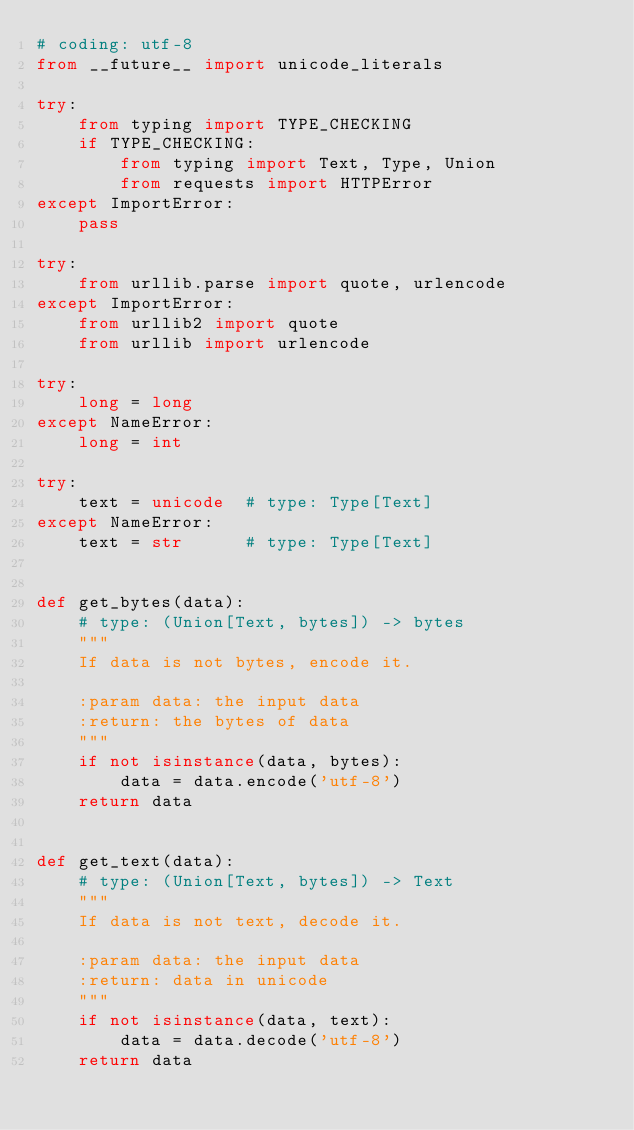<code> <loc_0><loc_0><loc_500><loc_500><_Python_># coding: utf-8
from __future__ import unicode_literals

try:
    from typing import TYPE_CHECKING
    if TYPE_CHECKING:
        from typing import Text, Type, Union
        from requests import HTTPError
except ImportError:
    pass

try:
    from urllib.parse import quote, urlencode
except ImportError:
    from urllib2 import quote
    from urllib import urlencode

try:
    long = long
except NameError:
    long = int

try:
    text = unicode  # type: Type[Text]
except NameError:
    text = str      # type: Type[Text]


def get_bytes(data):
    # type: (Union[Text, bytes]) -> bytes
    """
    If data is not bytes, encode it.

    :param data: the input data
    :return: the bytes of data
    """
    if not isinstance(data, bytes):
        data = data.encode('utf-8')
    return data


def get_text(data):
    # type: (Union[Text, bytes]) -> Text
    """
    If data is not text, decode it.

    :param data: the input data
    :return: data in unicode
    """
    if not isinstance(data, text):
        data = data.decode('utf-8')
    return data
</code> 